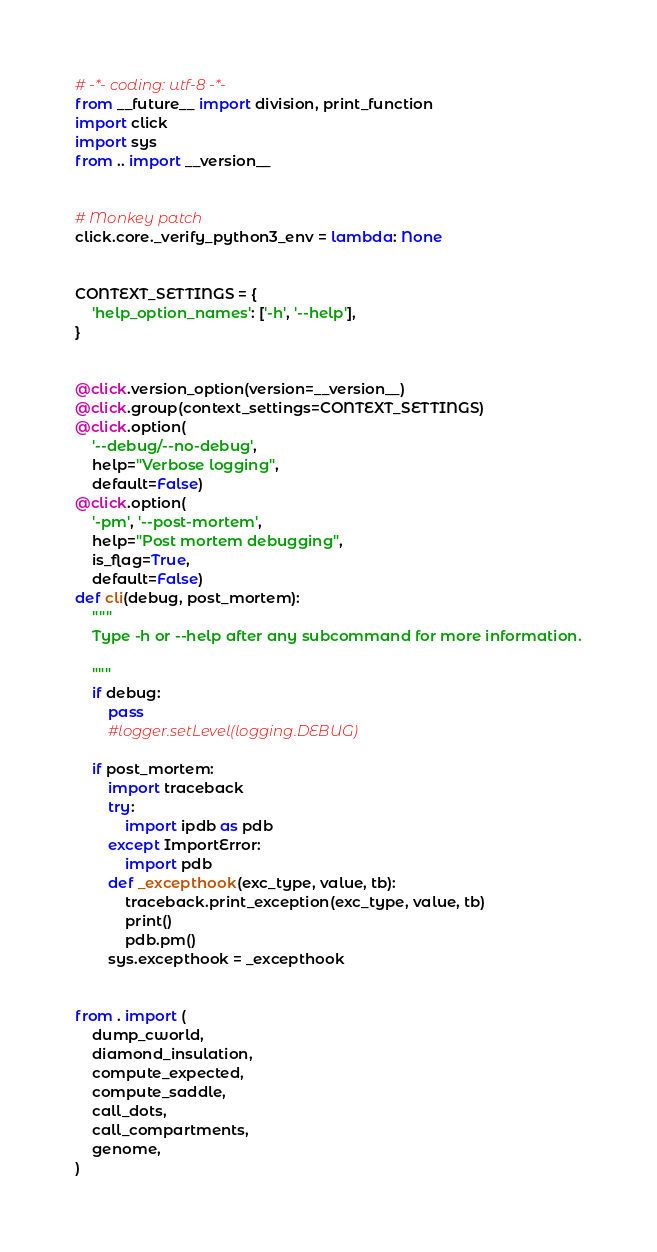Convert code to text. <code><loc_0><loc_0><loc_500><loc_500><_Python_># -*- coding: utf-8 -*-
from __future__ import division, print_function
import click
import sys
from .. import __version__


# Monkey patch
click.core._verify_python3_env = lambda: None


CONTEXT_SETTINGS = {
    'help_option_names': ['-h', '--help'],
}


@click.version_option(version=__version__)
@click.group(context_settings=CONTEXT_SETTINGS)
@click.option(
    '--debug/--no-debug', 
    help="Verbose logging", 
    default=False)
@click.option(
    '-pm', '--post-mortem', 
    help="Post mortem debugging", 
    is_flag=True,
    default=False)
def cli(debug, post_mortem):
    """
    Type -h or --help after any subcommand for more information.

    """
    if debug:
    	pass
        #logger.setLevel(logging.DEBUG)

    if post_mortem:
        import traceback
        try:
            import ipdb as pdb
        except ImportError:
            import pdb
        def _excepthook(exc_type, value, tb):
            traceback.print_exception(exc_type, value, tb)
            print()
            pdb.pm()
        sys.excepthook = _excepthook


from . import (
    dump_cworld,
    diamond_insulation,
    compute_expected,
    compute_saddle,
    call_dots,
    call_compartments,
    genome,
)
</code> 